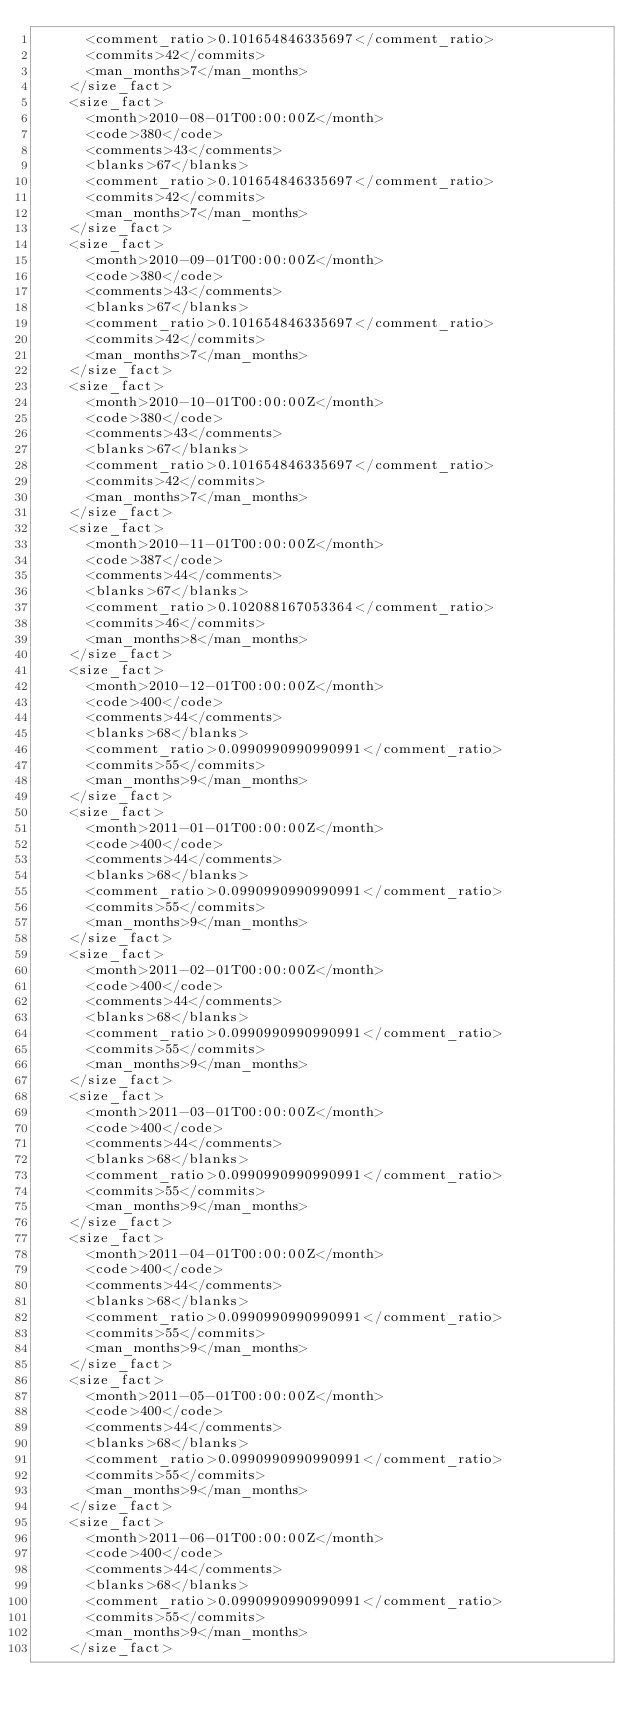Convert code to text. <code><loc_0><loc_0><loc_500><loc_500><_XML_>      <comment_ratio>0.101654846335697</comment_ratio>
      <commits>42</commits>
      <man_months>7</man_months>
    </size_fact>
    <size_fact>
      <month>2010-08-01T00:00:00Z</month>
      <code>380</code>
      <comments>43</comments>
      <blanks>67</blanks>
      <comment_ratio>0.101654846335697</comment_ratio>
      <commits>42</commits>
      <man_months>7</man_months>
    </size_fact>
    <size_fact>
      <month>2010-09-01T00:00:00Z</month>
      <code>380</code>
      <comments>43</comments>
      <blanks>67</blanks>
      <comment_ratio>0.101654846335697</comment_ratio>
      <commits>42</commits>
      <man_months>7</man_months>
    </size_fact>
    <size_fact>
      <month>2010-10-01T00:00:00Z</month>
      <code>380</code>
      <comments>43</comments>
      <blanks>67</blanks>
      <comment_ratio>0.101654846335697</comment_ratio>
      <commits>42</commits>
      <man_months>7</man_months>
    </size_fact>
    <size_fact>
      <month>2010-11-01T00:00:00Z</month>
      <code>387</code>
      <comments>44</comments>
      <blanks>67</blanks>
      <comment_ratio>0.102088167053364</comment_ratio>
      <commits>46</commits>
      <man_months>8</man_months>
    </size_fact>
    <size_fact>
      <month>2010-12-01T00:00:00Z</month>
      <code>400</code>
      <comments>44</comments>
      <blanks>68</blanks>
      <comment_ratio>0.0990990990990991</comment_ratio>
      <commits>55</commits>
      <man_months>9</man_months>
    </size_fact>
    <size_fact>
      <month>2011-01-01T00:00:00Z</month>
      <code>400</code>
      <comments>44</comments>
      <blanks>68</blanks>
      <comment_ratio>0.0990990990990991</comment_ratio>
      <commits>55</commits>
      <man_months>9</man_months>
    </size_fact>
    <size_fact>
      <month>2011-02-01T00:00:00Z</month>
      <code>400</code>
      <comments>44</comments>
      <blanks>68</blanks>
      <comment_ratio>0.0990990990990991</comment_ratio>
      <commits>55</commits>
      <man_months>9</man_months>
    </size_fact>
    <size_fact>
      <month>2011-03-01T00:00:00Z</month>
      <code>400</code>
      <comments>44</comments>
      <blanks>68</blanks>
      <comment_ratio>0.0990990990990991</comment_ratio>
      <commits>55</commits>
      <man_months>9</man_months>
    </size_fact>
    <size_fact>
      <month>2011-04-01T00:00:00Z</month>
      <code>400</code>
      <comments>44</comments>
      <blanks>68</blanks>
      <comment_ratio>0.0990990990990991</comment_ratio>
      <commits>55</commits>
      <man_months>9</man_months>
    </size_fact>
    <size_fact>
      <month>2011-05-01T00:00:00Z</month>
      <code>400</code>
      <comments>44</comments>
      <blanks>68</blanks>
      <comment_ratio>0.0990990990990991</comment_ratio>
      <commits>55</commits>
      <man_months>9</man_months>
    </size_fact>
    <size_fact>
      <month>2011-06-01T00:00:00Z</month>
      <code>400</code>
      <comments>44</comments>
      <blanks>68</blanks>
      <comment_ratio>0.0990990990990991</comment_ratio>
      <commits>55</commits>
      <man_months>9</man_months>
    </size_fact></code> 